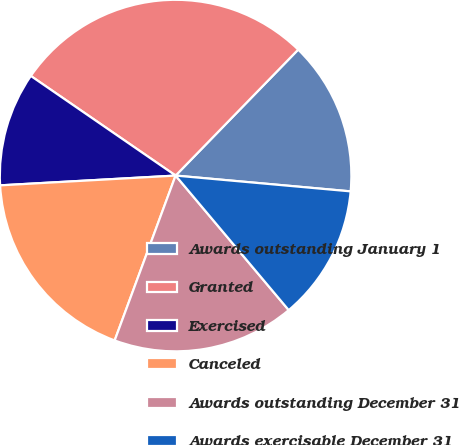Convert chart. <chart><loc_0><loc_0><loc_500><loc_500><pie_chart><fcel>Awards outstanding January 1<fcel>Granted<fcel>Exercised<fcel>Canceled<fcel>Awards outstanding December 31<fcel>Awards exercisable December 31<nl><fcel>14.15%<fcel>27.69%<fcel>10.48%<fcel>18.48%<fcel>16.76%<fcel>12.44%<nl></chart> 